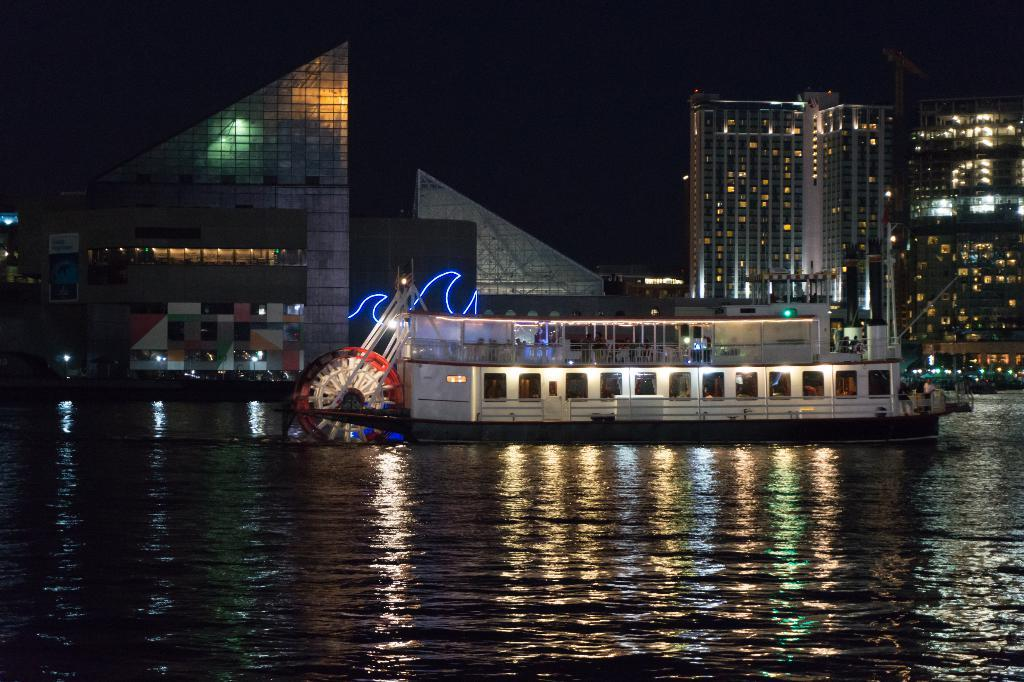What is located in the water in the image? There is a boat in the water in the image. Can you describe the people in the image? There are people in the image, but their specific actions or appearances are not mentioned in the facts. What type of structures can be seen in the image? There are buildings in the image. What else is visible in the image besides the boat and buildings? Lights and objects are visible in the image. How would you describe the overall appearance of the image? The background of the image is dark. What type of tin is being used by the minister in the image? There is no mention of a minister or tin in the image, so this question cannot be answered definitively. 